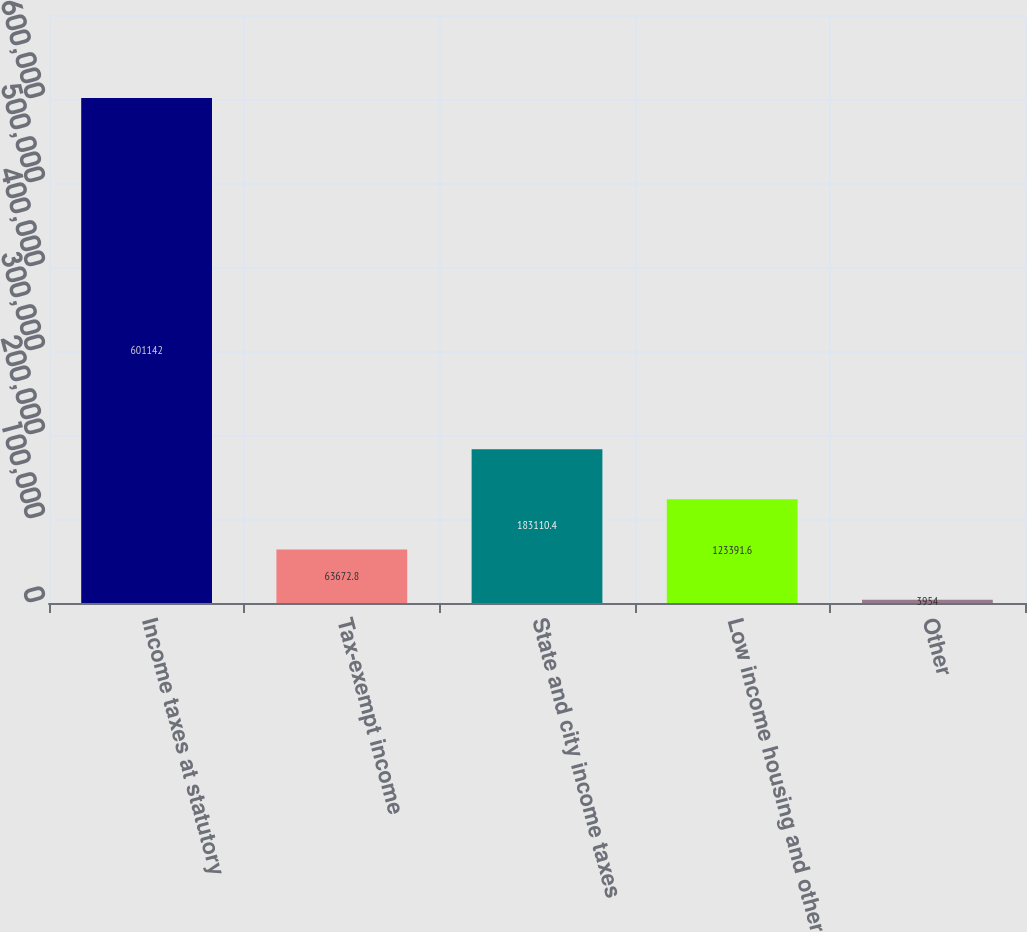<chart> <loc_0><loc_0><loc_500><loc_500><bar_chart><fcel>Income taxes at statutory<fcel>Tax-exempt income<fcel>State and city income taxes<fcel>Low income housing and other<fcel>Other<nl><fcel>601142<fcel>63672.8<fcel>183110<fcel>123392<fcel>3954<nl></chart> 